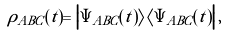Convert formula to latex. <formula><loc_0><loc_0><loc_500><loc_500>\rho _ { A B C } ( t ) = \left | \Psi _ { A B C } ( t ) \right \rangle \left \langle \Psi _ { A B C } ( t ) \right | ,</formula> 